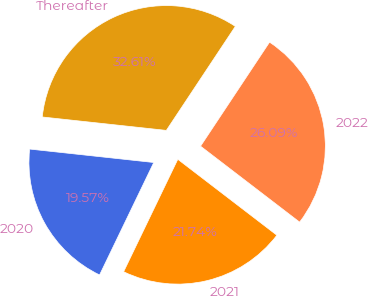Convert chart to OTSL. <chart><loc_0><loc_0><loc_500><loc_500><pie_chart><fcel>2020<fcel>2021<fcel>2022<fcel>Thereafter<nl><fcel>19.57%<fcel>21.74%<fcel>26.09%<fcel>32.61%<nl></chart> 